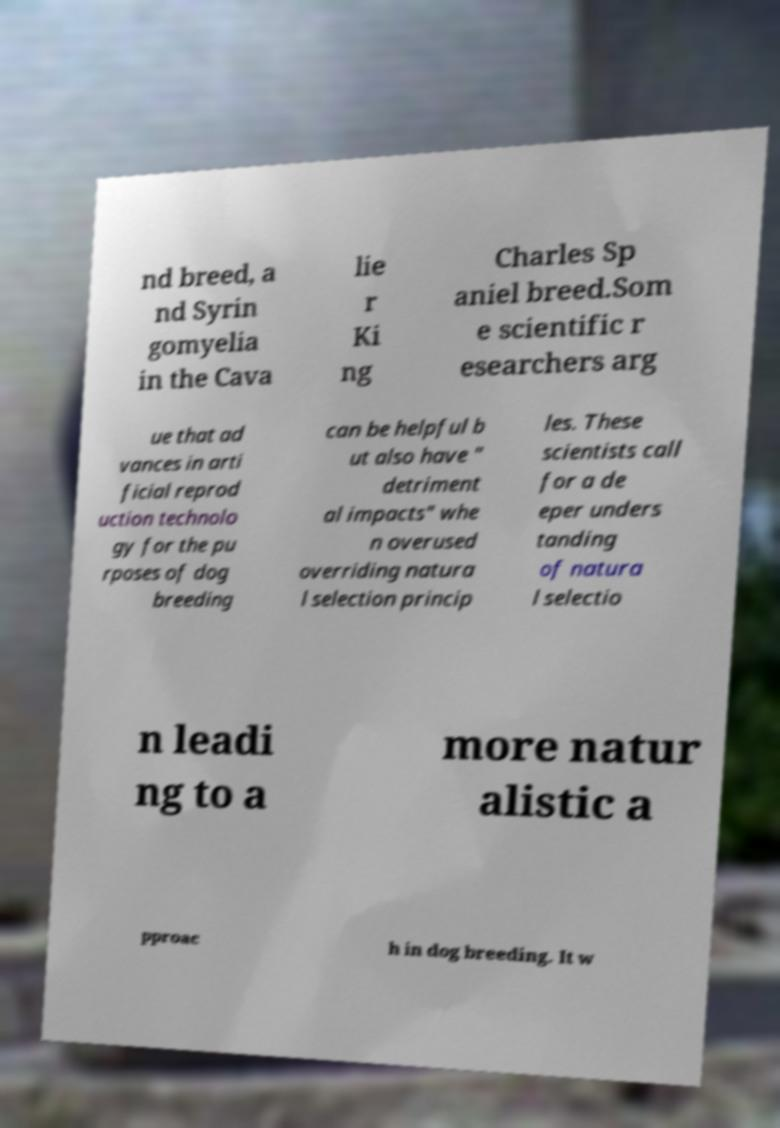Please read and relay the text visible in this image. What does it say? nd breed, a nd Syrin gomyelia in the Cava lie r Ki ng Charles Sp aniel breed.Som e scientific r esearchers arg ue that ad vances in arti ficial reprod uction technolo gy for the pu rposes of dog breeding can be helpful b ut also have " detriment al impacts" whe n overused overriding natura l selection princip les. These scientists call for a de eper unders tanding of natura l selectio n leadi ng to a more natur alistic a pproac h in dog breeding. It w 